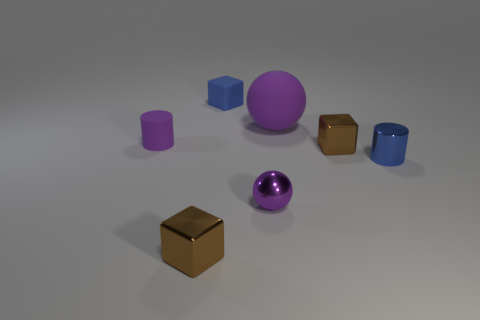Subtract all brown cubes. How many were subtracted if there are1brown cubes left? 1 Add 1 cyan cylinders. How many objects exist? 8 Subtract all balls. How many objects are left? 5 Add 7 blue cubes. How many blue cubes are left? 8 Add 1 tiny shiny objects. How many tiny shiny objects exist? 5 Subtract 0 green cylinders. How many objects are left? 7 Subtract all big spheres. Subtract all brown blocks. How many objects are left? 4 